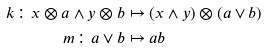<formula> <loc_0><loc_0><loc_500><loc_500>k \colon x \otimes a \wedge y \otimes b & \mapsto ( x \wedge y ) \otimes ( a \vee b ) \\ m \colon a \vee b & \mapsto a b</formula> 